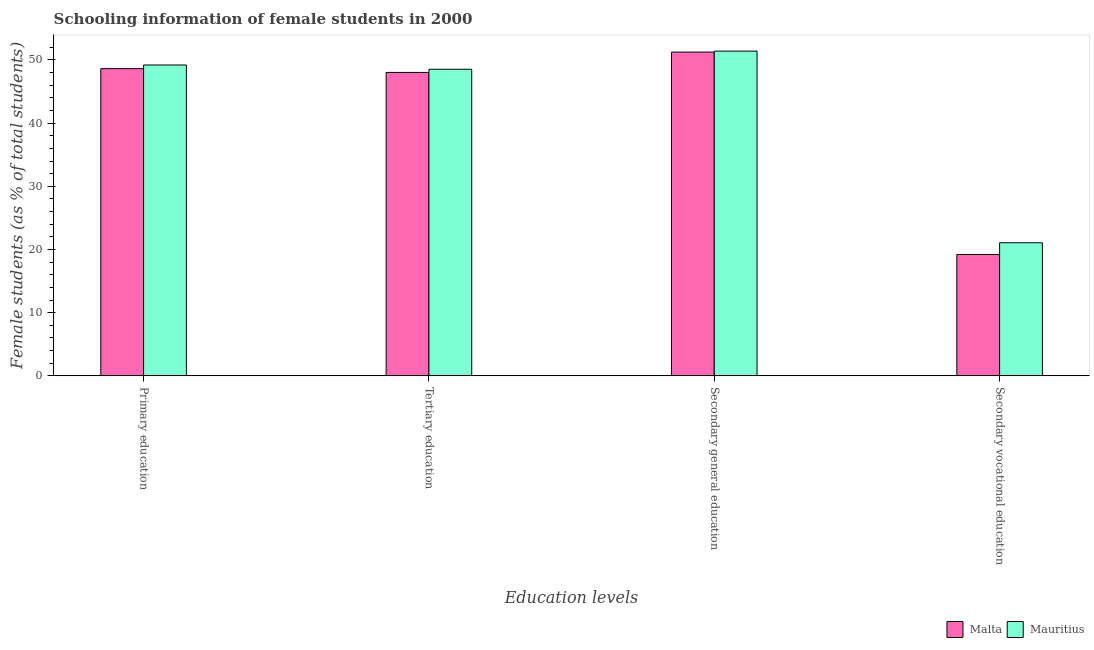How many groups of bars are there?
Offer a very short reply. 4. How many bars are there on the 3rd tick from the left?
Ensure brevity in your answer.  2. How many bars are there on the 4th tick from the right?
Your answer should be compact. 2. What is the label of the 3rd group of bars from the left?
Offer a very short reply. Secondary general education. What is the percentage of female students in secondary education in Malta?
Ensure brevity in your answer.  51.24. Across all countries, what is the maximum percentage of female students in primary education?
Keep it short and to the point. 49.19. Across all countries, what is the minimum percentage of female students in secondary vocational education?
Offer a very short reply. 19.21. In which country was the percentage of female students in tertiary education maximum?
Make the answer very short. Mauritius. In which country was the percentage of female students in secondary education minimum?
Offer a very short reply. Malta. What is the total percentage of female students in secondary education in the graph?
Your response must be concise. 102.63. What is the difference between the percentage of female students in secondary vocational education in Mauritius and that in Malta?
Offer a terse response. 1.86. What is the difference between the percentage of female students in primary education in Mauritius and the percentage of female students in tertiary education in Malta?
Provide a short and direct response. 1.18. What is the average percentage of female students in tertiary education per country?
Give a very brief answer. 48.27. What is the difference between the percentage of female students in secondary education and percentage of female students in primary education in Malta?
Make the answer very short. 2.62. In how many countries, is the percentage of female students in secondary vocational education greater than 34 %?
Offer a terse response. 0. What is the ratio of the percentage of female students in primary education in Malta to that in Mauritius?
Provide a succinct answer. 0.99. Is the percentage of female students in primary education in Mauritius less than that in Malta?
Your response must be concise. No. What is the difference between the highest and the second highest percentage of female students in secondary education?
Your answer should be compact. 0.15. What is the difference between the highest and the lowest percentage of female students in primary education?
Offer a terse response. 0.58. Is the sum of the percentage of female students in secondary vocational education in Mauritius and Malta greater than the maximum percentage of female students in tertiary education across all countries?
Make the answer very short. No. Is it the case that in every country, the sum of the percentage of female students in secondary education and percentage of female students in tertiary education is greater than the sum of percentage of female students in primary education and percentage of female students in secondary vocational education?
Provide a short and direct response. Yes. What does the 1st bar from the left in Secondary vocational education represents?
Your response must be concise. Malta. What does the 1st bar from the right in Secondary general education represents?
Your answer should be very brief. Mauritius. Is it the case that in every country, the sum of the percentage of female students in primary education and percentage of female students in tertiary education is greater than the percentage of female students in secondary education?
Offer a very short reply. Yes. Are all the bars in the graph horizontal?
Provide a short and direct response. No. Are the values on the major ticks of Y-axis written in scientific E-notation?
Your answer should be compact. No. What is the title of the graph?
Your answer should be very brief. Schooling information of female students in 2000. Does "East Asia (developing only)" appear as one of the legend labels in the graph?
Provide a succinct answer. No. What is the label or title of the X-axis?
Your response must be concise. Education levels. What is the label or title of the Y-axis?
Your response must be concise. Female students (as % of total students). What is the Female students (as % of total students) in Malta in Primary education?
Your answer should be very brief. 48.62. What is the Female students (as % of total students) of Mauritius in Primary education?
Offer a terse response. 49.19. What is the Female students (as % of total students) of Malta in Tertiary education?
Provide a succinct answer. 48.02. What is the Female students (as % of total students) of Mauritius in Tertiary education?
Offer a terse response. 48.52. What is the Female students (as % of total students) in Malta in Secondary general education?
Your answer should be compact. 51.24. What is the Female students (as % of total students) in Mauritius in Secondary general education?
Keep it short and to the point. 51.39. What is the Female students (as % of total students) in Malta in Secondary vocational education?
Your answer should be very brief. 19.21. What is the Female students (as % of total students) in Mauritius in Secondary vocational education?
Provide a short and direct response. 21.06. Across all Education levels, what is the maximum Female students (as % of total students) in Malta?
Ensure brevity in your answer.  51.24. Across all Education levels, what is the maximum Female students (as % of total students) of Mauritius?
Offer a very short reply. 51.39. Across all Education levels, what is the minimum Female students (as % of total students) in Malta?
Ensure brevity in your answer.  19.21. Across all Education levels, what is the minimum Female students (as % of total students) in Mauritius?
Keep it short and to the point. 21.06. What is the total Female students (as % of total students) in Malta in the graph?
Ensure brevity in your answer.  167.07. What is the total Female students (as % of total students) in Mauritius in the graph?
Provide a succinct answer. 170.16. What is the difference between the Female students (as % of total students) of Malta in Primary education and that in Tertiary education?
Ensure brevity in your answer.  0.6. What is the difference between the Female students (as % of total students) in Mauritius in Primary education and that in Tertiary education?
Offer a terse response. 0.68. What is the difference between the Female students (as % of total students) of Malta in Primary education and that in Secondary general education?
Your answer should be compact. -2.62. What is the difference between the Female students (as % of total students) of Mauritius in Primary education and that in Secondary general education?
Offer a terse response. -2.2. What is the difference between the Female students (as % of total students) in Malta in Primary education and that in Secondary vocational education?
Provide a short and direct response. 29.41. What is the difference between the Female students (as % of total students) of Mauritius in Primary education and that in Secondary vocational education?
Make the answer very short. 28.13. What is the difference between the Female students (as % of total students) of Malta in Tertiary education and that in Secondary general education?
Provide a short and direct response. -3.22. What is the difference between the Female students (as % of total students) in Mauritius in Tertiary education and that in Secondary general education?
Give a very brief answer. -2.87. What is the difference between the Female students (as % of total students) in Malta in Tertiary education and that in Secondary vocational education?
Ensure brevity in your answer.  28.81. What is the difference between the Female students (as % of total students) in Mauritius in Tertiary education and that in Secondary vocational education?
Your answer should be very brief. 27.45. What is the difference between the Female students (as % of total students) in Malta in Secondary general education and that in Secondary vocational education?
Give a very brief answer. 32.03. What is the difference between the Female students (as % of total students) in Mauritius in Secondary general education and that in Secondary vocational education?
Your answer should be compact. 30.32. What is the difference between the Female students (as % of total students) in Malta in Primary education and the Female students (as % of total students) in Mauritius in Tertiary education?
Provide a succinct answer. 0.1. What is the difference between the Female students (as % of total students) in Malta in Primary education and the Female students (as % of total students) in Mauritius in Secondary general education?
Make the answer very short. -2.77. What is the difference between the Female students (as % of total students) in Malta in Primary education and the Female students (as % of total students) in Mauritius in Secondary vocational education?
Make the answer very short. 27.55. What is the difference between the Female students (as % of total students) in Malta in Tertiary education and the Female students (as % of total students) in Mauritius in Secondary general education?
Give a very brief answer. -3.37. What is the difference between the Female students (as % of total students) in Malta in Tertiary education and the Female students (as % of total students) in Mauritius in Secondary vocational education?
Provide a short and direct response. 26.95. What is the difference between the Female students (as % of total students) of Malta in Secondary general education and the Female students (as % of total students) of Mauritius in Secondary vocational education?
Make the answer very short. 30.17. What is the average Female students (as % of total students) of Malta per Education levels?
Provide a short and direct response. 41.77. What is the average Female students (as % of total students) in Mauritius per Education levels?
Keep it short and to the point. 42.54. What is the difference between the Female students (as % of total students) in Malta and Female students (as % of total students) in Mauritius in Primary education?
Ensure brevity in your answer.  -0.58. What is the difference between the Female students (as % of total students) in Malta and Female students (as % of total students) in Mauritius in Tertiary education?
Make the answer very short. -0.5. What is the difference between the Female students (as % of total students) of Malta and Female students (as % of total students) of Mauritius in Secondary general education?
Keep it short and to the point. -0.15. What is the difference between the Female students (as % of total students) in Malta and Female students (as % of total students) in Mauritius in Secondary vocational education?
Ensure brevity in your answer.  -1.86. What is the ratio of the Female students (as % of total students) in Malta in Primary education to that in Tertiary education?
Ensure brevity in your answer.  1.01. What is the ratio of the Female students (as % of total students) in Mauritius in Primary education to that in Tertiary education?
Keep it short and to the point. 1.01. What is the ratio of the Female students (as % of total students) in Malta in Primary education to that in Secondary general education?
Provide a short and direct response. 0.95. What is the ratio of the Female students (as % of total students) of Mauritius in Primary education to that in Secondary general education?
Make the answer very short. 0.96. What is the ratio of the Female students (as % of total students) in Malta in Primary education to that in Secondary vocational education?
Your answer should be compact. 2.53. What is the ratio of the Female students (as % of total students) in Mauritius in Primary education to that in Secondary vocational education?
Keep it short and to the point. 2.34. What is the ratio of the Female students (as % of total students) of Malta in Tertiary education to that in Secondary general education?
Provide a short and direct response. 0.94. What is the ratio of the Female students (as % of total students) of Mauritius in Tertiary education to that in Secondary general education?
Your response must be concise. 0.94. What is the ratio of the Female students (as % of total students) in Malta in Tertiary education to that in Secondary vocational education?
Keep it short and to the point. 2.5. What is the ratio of the Female students (as % of total students) in Mauritius in Tertiary education to that in Secondary vocational education?
Provide a short and direct response. 2.3. What is the ratio of the Female students (as % of total students) of Malta in Secondary general education to that in Secondary vocational education?
Provide a succinct answer. 2.67. What is the ratio of the Female students (as % of total students) in Mauritius in Secondary general education to that in Secondary vocational education?
Offer a terse response. 2.44. What is the difference between the highest and the second highest Female students (as % of total students) of Malta?
Offer a very short reply. 2.62. What is the difference between the highest and the second highest Female students (as % of total students) in Mauritius?
Your answer should be compact. 2.2. What is the difference between the highest and the lowest Female students (as % of total students) in Malta?
Make the answer very short. 32.03. What is the difference between the highest and the lowest Female students (as % of total students) of Mauritius?
Offer a very short reply. 30.32. 